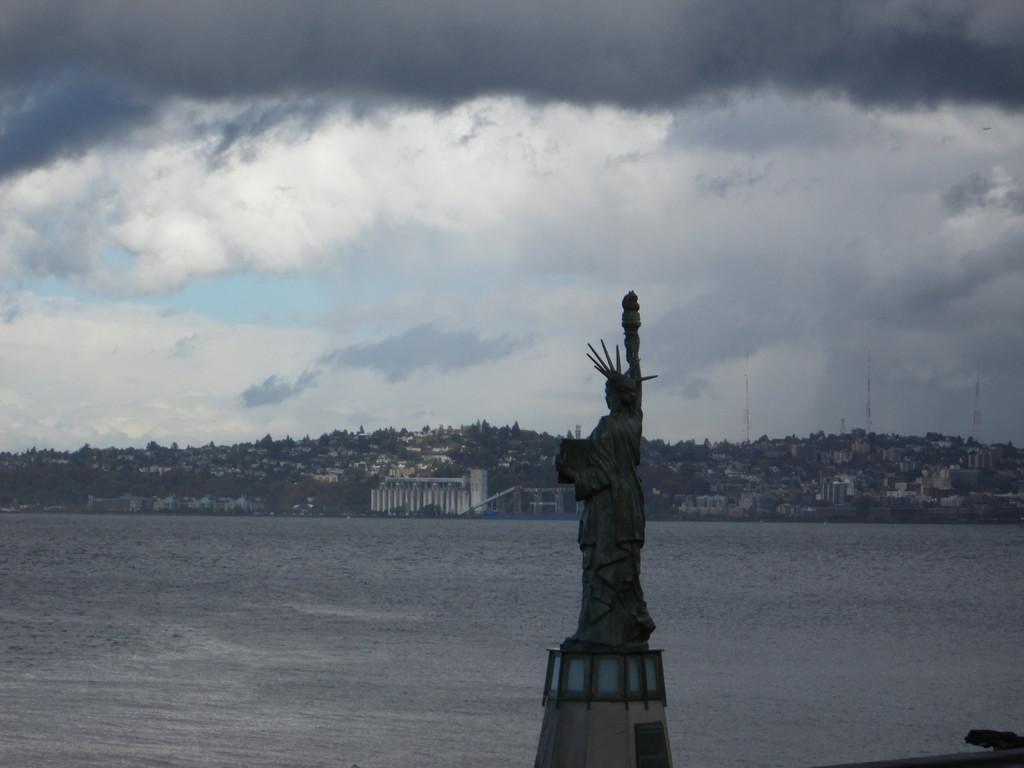Can you describe this image briefly? In this image we can see the statue and we can see the river and in the background, we can see some buildings and at the top we can see the sky with clouds. 